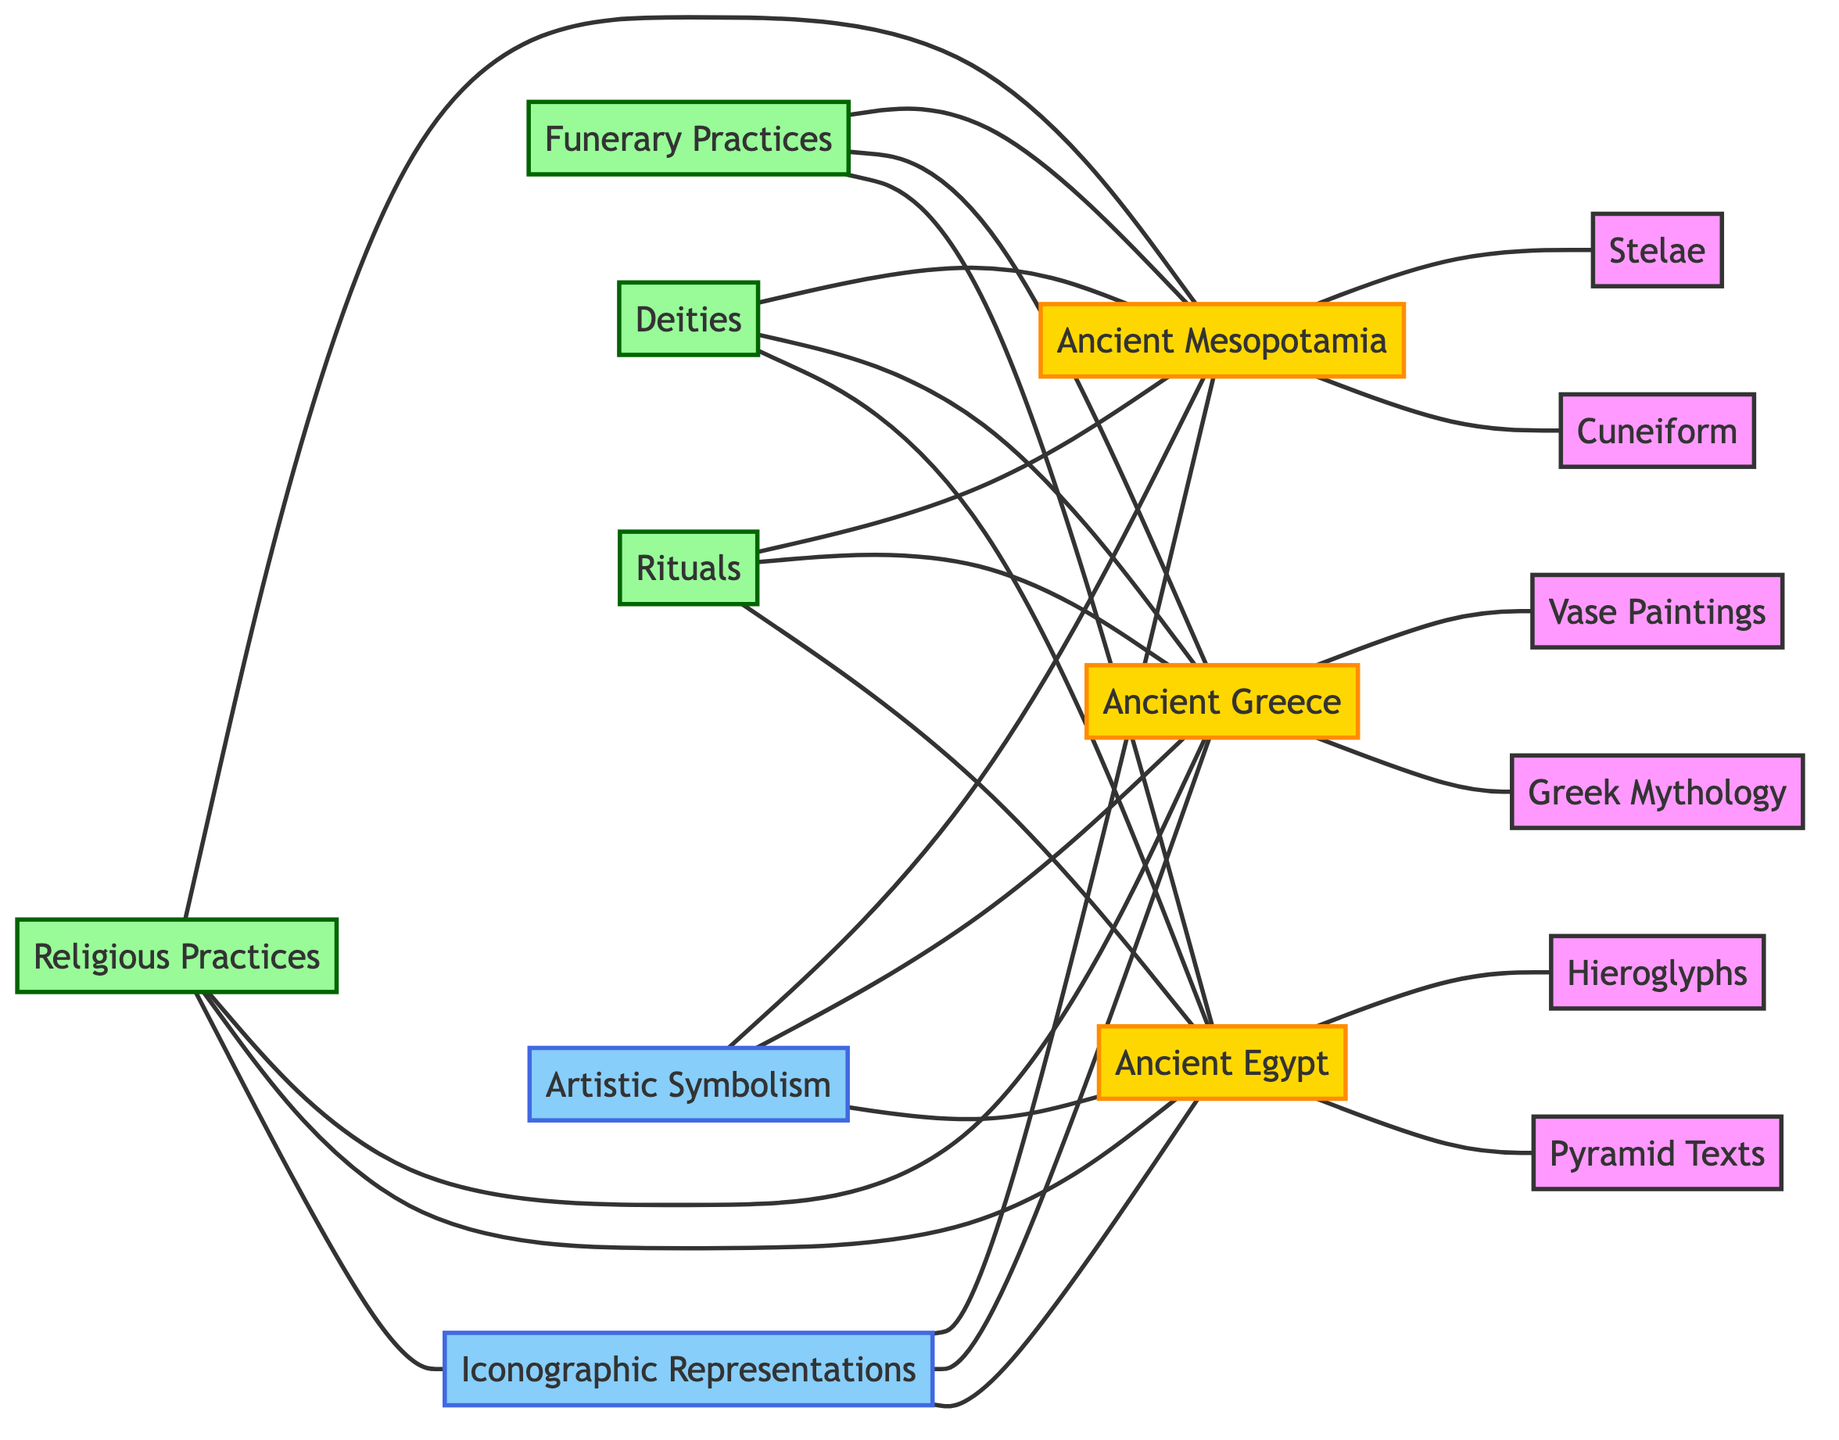What are the two main categories represented in this diagram? The diagram includes "Religious Practices" and "Iconographic Representations" as the main categories connected with an edge. These represent the overarching themes of the relationships depicted.
Answer: Religious Practices, Iconographic Representations How many ancient societies are represented in the diagram? There are three ancient societies represented in the diagram: Ancient Egypt, Ancient Greece, and Ancient Mesopotamia. Each is connected to the main categories and their respective iconographic representations.
Answer: 3 Which iconographic representation is associated with Ancient Egypt? The diagram indicates that both "Pyramid Texts" and "Hieroglyphs" are associated with Ancient Egypt, as they are connected directly to the Ancient Egypt node.
Answer: Pyramid Texts, Hieroglyphs What type of practices does "Funerary Practices" belong to? "Funerary Practices" is connected to "Religious Practices," indicating that it falls under the category of religious practices within Ancient Egypt, Greece, and Mesopotamia.
Answer: Religious Practices How are "Rituals" connected to Ancient Greece? The "Rituals" node is connected to Ancient Greece through an edge, showing that rituals are part of the religious practices within that ancient society.
Answer: Through an edge Which type of artistic representation is specifically linked to Ancient Greece? The diagram shows that "Vase Paintings" is specifically represented as an artistic expression in Ancient Greece, connected directly to the Ancient Greece node.
Answer: Vase Paintings What does the edge between "Deities" and "Ancient Mesopotamia" represent? The edge indicates that the concept of "Deities" is related to religious practices within Ancient Mesopotamia, suggesting the importance of deities in their iconography.
Answer: Relationship between Deities and Ancient Mesopotamia List one form of iconographic representation linked to Ancient Mesopotamia. "Cuneiform" and "Stelae" are both forms of iconographic representation linked to Ancient Mesopotamia, as shown by the connections in the diagram.
Answer: Cuneiform or Stelae How many nodes are connected to "Iconographic Representations"? There are three nodes connected to "Iconographic Representations," specifically, Ancient Egypt, Ancient Greece, and Ancient Mesopotamia, as seen in the edges leading from the iconographic category.
Answer: 3 